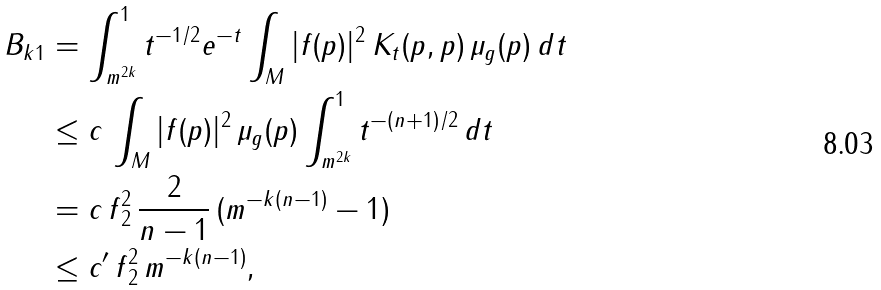Convert formula to latex. <formula><loc_0><loc_0><loc_500><loc_500>\| B _ { k } \| _ { 1 } & = \int _ { m ^ { 2 k } } ^ { 1 } t ^ { - 1 / 2 } e ^ { - t } \int _ { M } | f ( p ) | ^ { 2 } \, K _ { t } ( p , p ) \, \mu _ { g } ( p ) \, d t \\ & \leq c \, \int _ { M } | f ( p ) | ^ { 2 } \, \mu _ { g } ( p ) \int _ { m ^ { 2 k } } ^ { 1 } t ^ { - ( n + 1 ) / 2 } \, d t \\ & = c \, \| f \| _ { 2 } ^ { 2 } \, \frac { 2 } { n - 1 } \, ( m ^ { - k ( n - 1 ) } - 1 ) \\ & \leq c ^ { \prime } \, \| f \| _ { 2 } ^ { 2 } \, m ^ { - k ( n - 1 ) } ,</formula> 